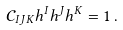<formula> <loc_0><loc_0><loc_500><loc_500>\mathcal { C } _ { I J K } h ^ { I } h ^ { J } h ^ { K } = 1 \, .</formula> 